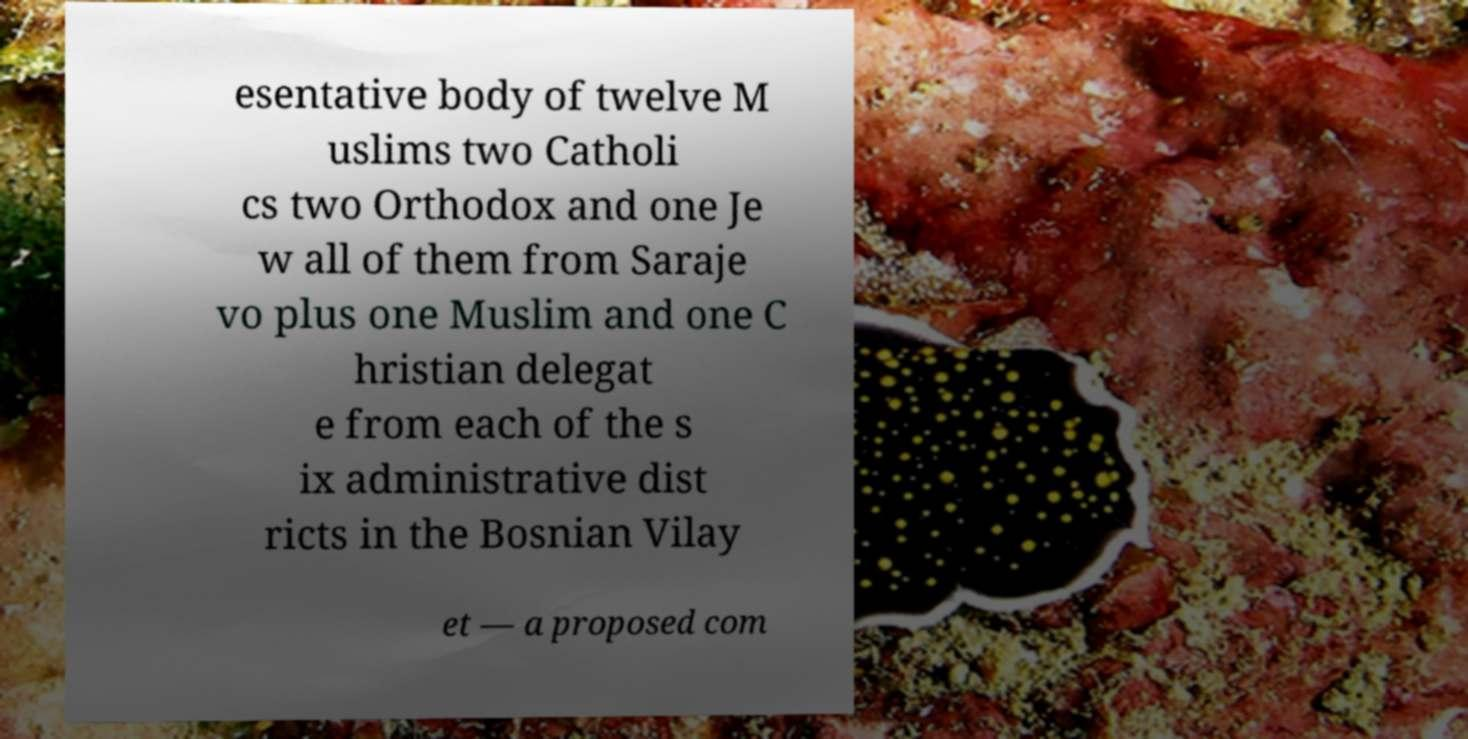I need the written content from this picture converted into text. Can you do that? esentative body of twelve M uslims two Catholi cs two Orthodox and one Je w all of them from Saraje vo plus one Muslim and one C hristian delegat e from each of the s ix administrative dist ricts in the Bosnian Vilay et — a proposed com 